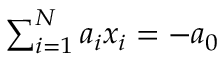<formula> <loc_0><loc_0><loc_500><loc_500>\sum _ { i = 1 } ^ { N } a _ { i } x _ { i } = - a _ { 0 }</formula> 